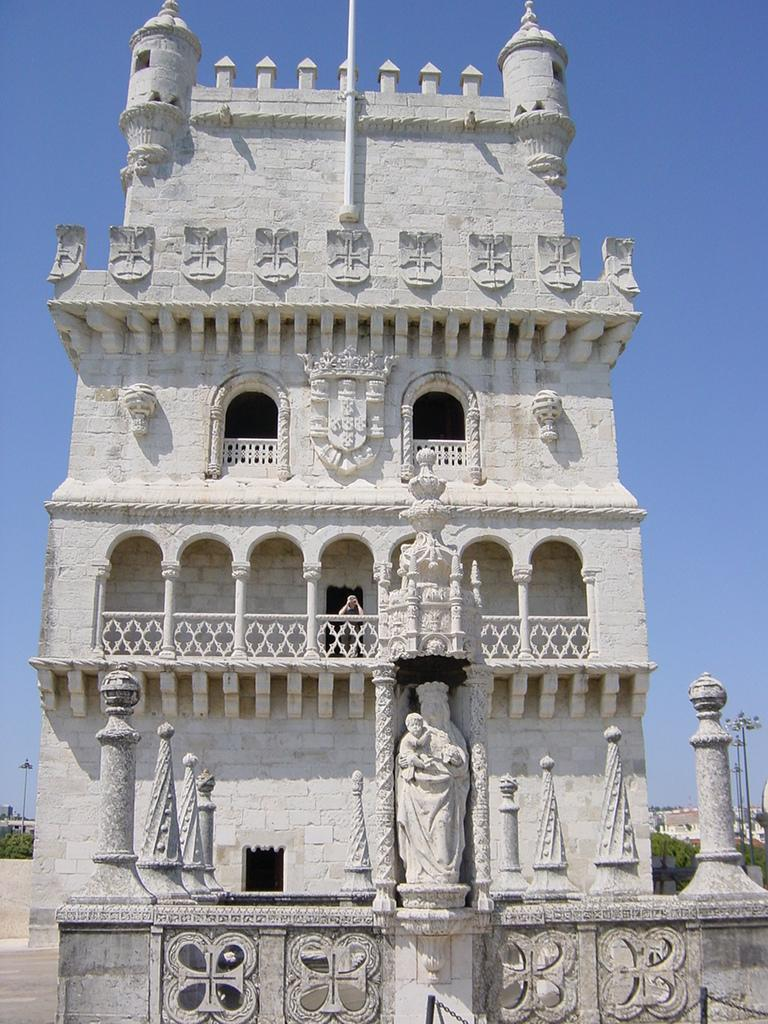What type of structure is visible in the image? There is a building in the image. What features can be seen on the building? The building has windows and a railing. What other objects are present in the image? There are statues, a group of poles, and a group of trees in the background of the image. What can be seen in the background of the image? There are light poles and the sky visible in the background of the image. What type of cakes are being served at the crime scene in the image? There is no crime scene or cakes present in the image. The image features a building with various objects and features, but no mention of cakes or a crime scene. 